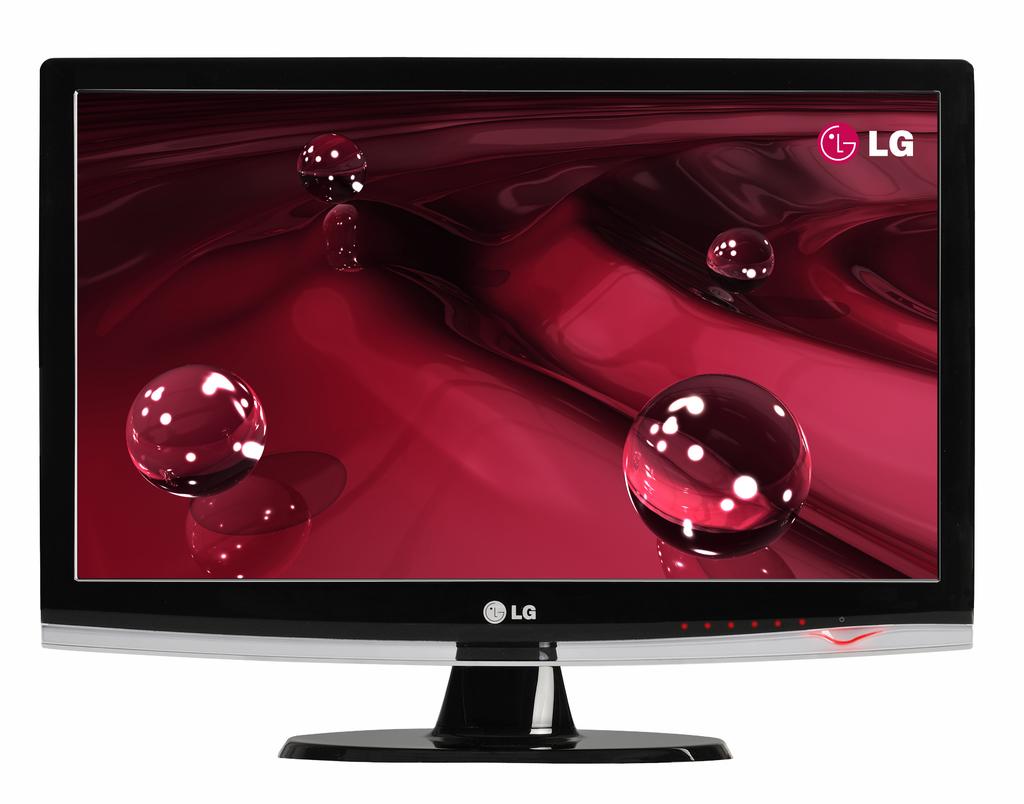What brand of tv is this?
Your answer should be compact. Lg. 